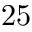<formula> <loc_0><loc_0><loc_500><loc_500>2 5</formula> 